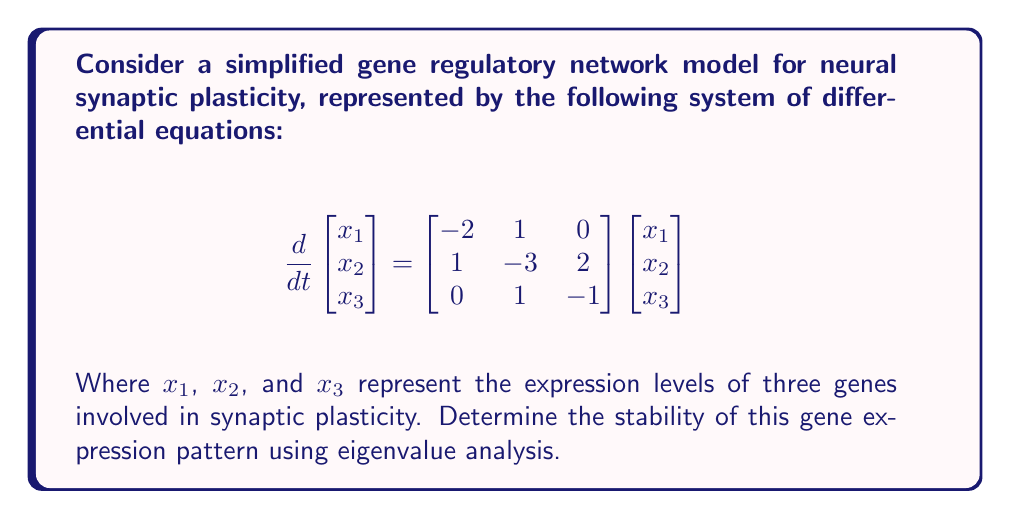Help me with this question. To determine the stability of the gene expression pattern, we need to analyze the eigenvalues of the system matrix:

1) First, we need to find the characteristic equation of the matrix:
   $$det(\lambda I - A) = 0$$
   Where $I$ is the 3x3 identity matrix and $A$ is the given system matrix.

2) Expanding the determinant:
   $$\begin{vmatrix} 
   \lambda+2 & -1 & 0 \\
   -1 & \lambda+3 & -2 \\
   0 & -1 & \lambda+1
   \end{vmatrix} = 0$$

3) This gives us the characteristic equation:
   $$(\lambda+2)[(\lambda+3)(\lambda+1) - 2] - (-1)[-1(\lambda+1)] = 0$$
   $$(\lambda+2)(\lambda^2+4\lambda+1) + (\lambda+1) = 0$$
   $$\lambda^3+6\lambda^2+9\lambda+2 = 0$$

4) To solve this cubic equation, we can use the rational root theorem or a computer algebra system. The roots are:
   $$\lambda_1 = -1, \lambda_2 = -2, \lambda_3 = -3$$

5) For stability, all eigenvalues must have negative real parts. In this case, all eigenvalues are real and negative.

Therefore, the gene expression pattern is stable, indicating that the synaptic plasticity regulated by these genes tends towards a stable equilibrium state.
Answer: Stable (eigenvalues: $-1, -2, -3$) 